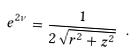<formula> <loc_0><loc_0><loc_500><loc_500>e ^ { 2 \nu } = \frac { 1 } { 2 \sqrt { r ^ { 2 } + z ^ { 2 } } } \ .</formula> 